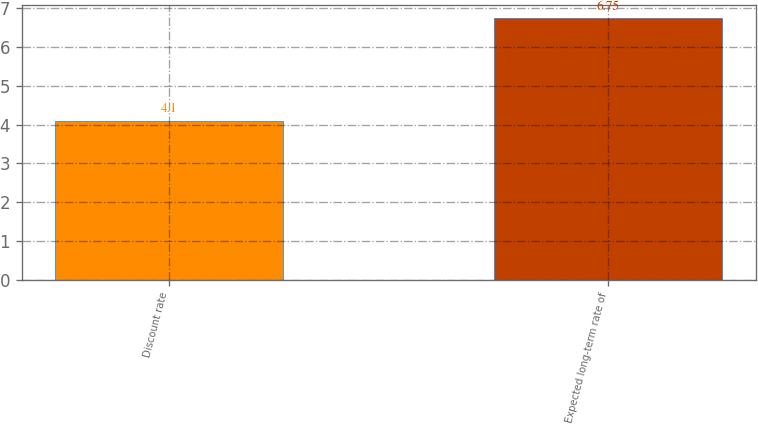<chart> <loc_0><loc_0><loc_500><loc_500><bar_chart><fcel>Discount rate<fcel>Expected long-term rate of<nl><fcel>4.1<fcel>6.75<nl></chart> 